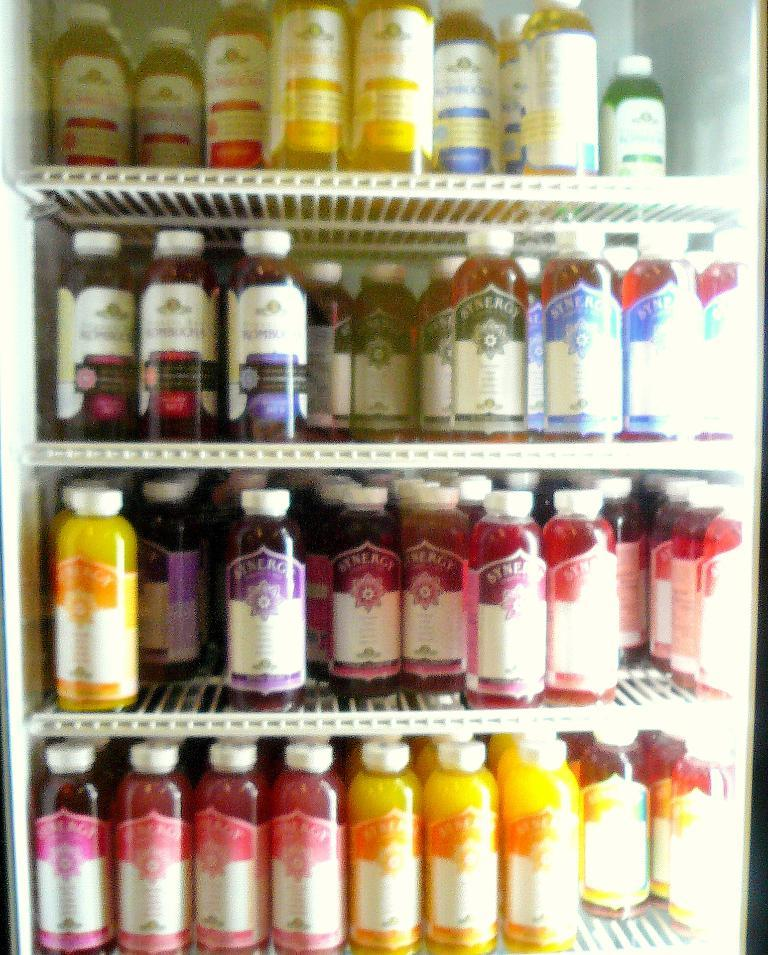What is present on the racks in the image? The racks contain bottles in the image. What can be found inside the bottles? The bottles have liquids of different colors. Can you name any specific colors of the liquids in the bottles? Yes, the colors mentioned are yellow and red. How does the snow affect the wing of the bird in the image? There is no snow or bird present in the image; it only features racks with bottles containing yellow and red liquids. 